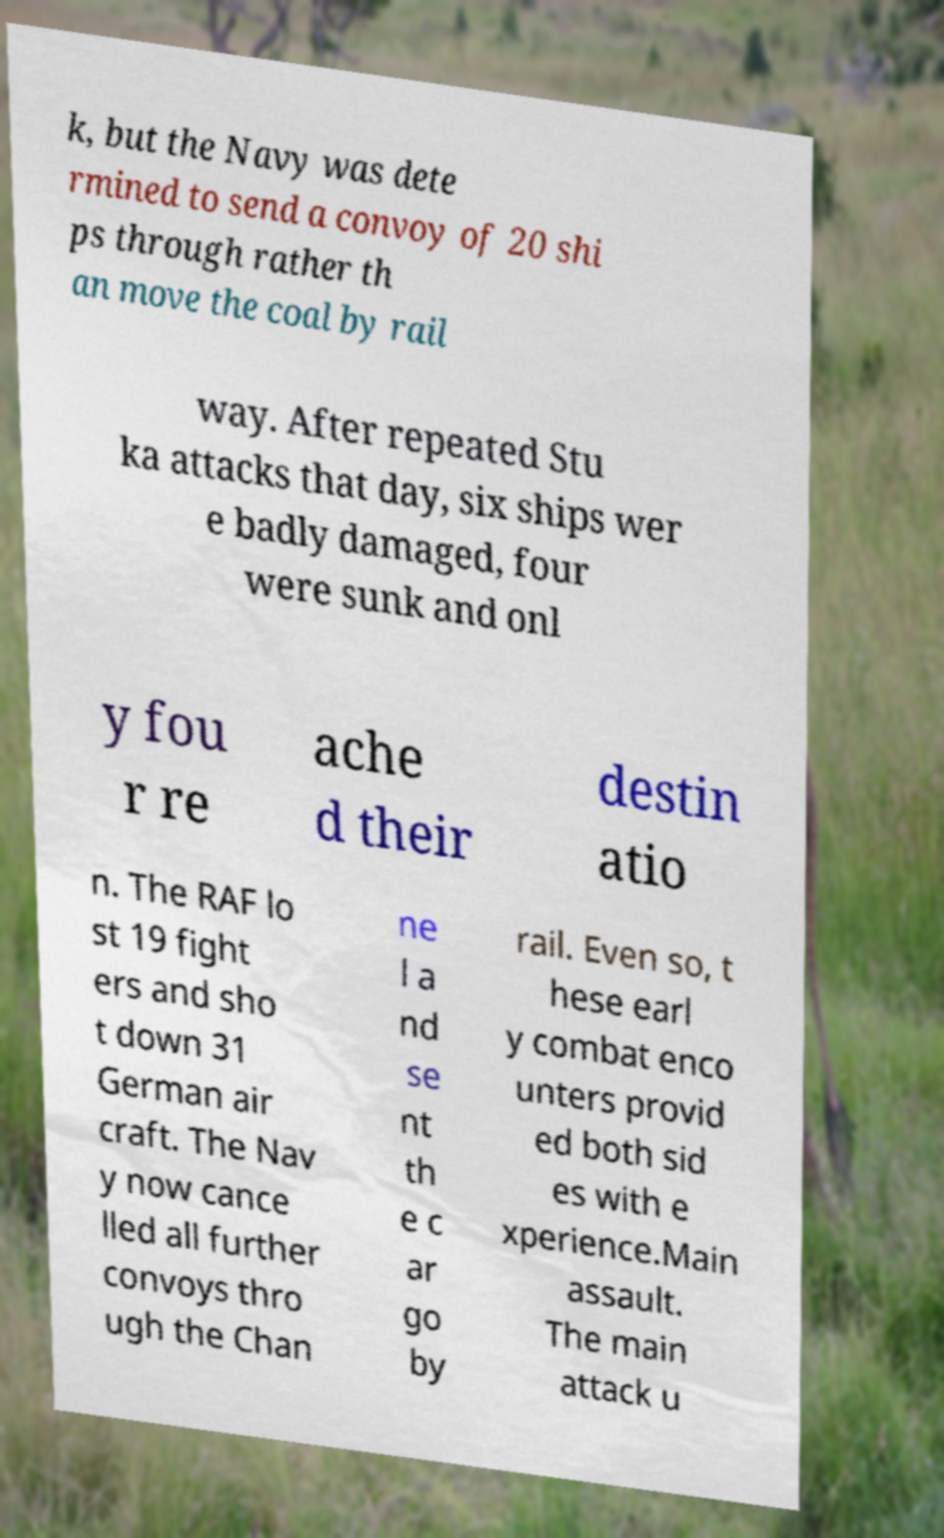Please read and relay the text visible in this image. What does it say? k, but the Navy was dete rmined to send a convoy of 20 shi ps through rather th an move the coal by rail way. After repeated Stu ka attacks that day, six ships wer e badly damaged, four were sunk and onl y fou r re ache d their destin atio n. The RAF lo st 19 fight ers and sho t down 31 German air craft. The Nav y now cance lled all further convoys thro ugh the Chan ne l a nd se nt th e c ar go by rail. Even so, t hese earl y combat enco unters provid ed both sid es with e xperience.Main assault. The main attack u 